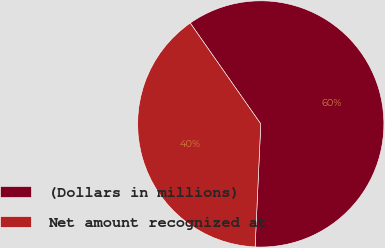Convert chart to OTSL. <chart><loc_0><loc_0><loc_500><loc_500><pie_chart><fcel>(Dollars in millions)<fcel>Net amount recognized at<nl><fcel>60.44%<fcel>39.56%<nl></chart> 